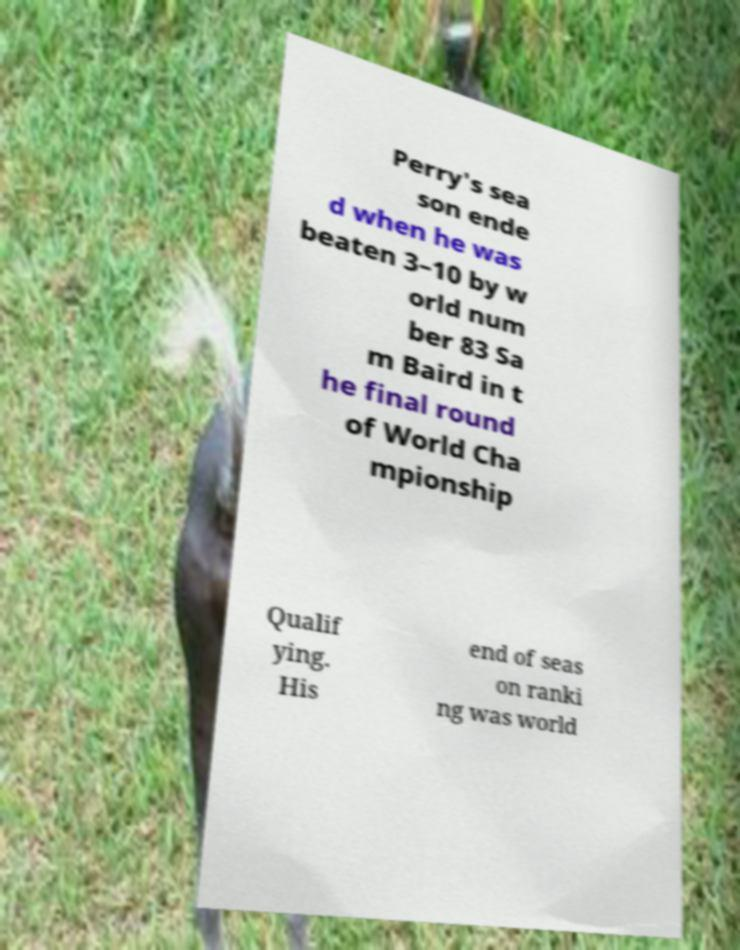Could you extract and type out the text from this image? Perry's sea son ende d when he was beaten 3–10 by w orld num ber 83 Sa m Baird in t he final round of World Cha mpionship Qualif ying. His end of seas on ranki ng was world 